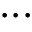Convert formula to latex. <formula><loc_0><loc_0><loc_500><loc_500>\dots</formula> 